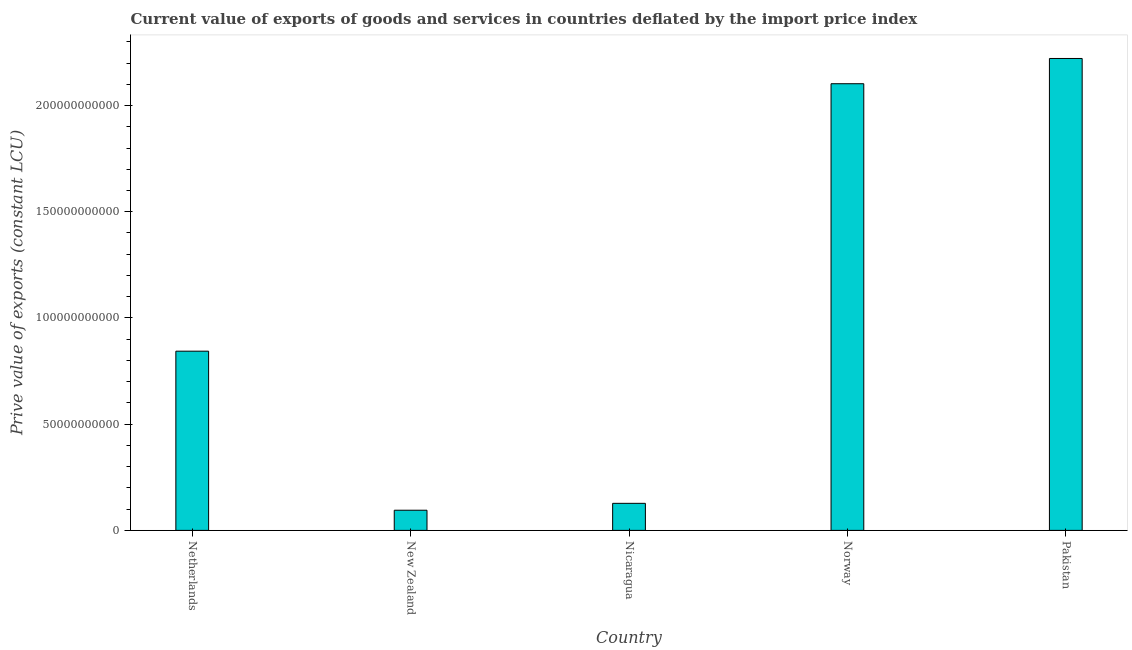Does the graph contain any zero values?
Your answer should be very brief. No. What is the title of the graph?
Keep it short and to the point. Current value of exports of goods and services in countries deflated by the import price index. What is the label or title of the X-axis?
Your answer should be compact. Country. What is the label or title of the Y-axis?
Offer a terse response. Prive value of exports (constant LCU). What is the price value of exports in New Zealand?
Keep it short and to the point. 9.49e+09. Across all countries, what is the maximum price value of exports?
Your answer should be compact. 2.22e+11. Across all countries, what is the minimum price value of exports?
Give a very brief answer. 9.49e+09. In which country was the price value of exports maximum?
Make the answer very short. Pakistan. In which country was the price value of exports minimum?
Keep it short and to the point. New Zealand. What is the sum of the price value of exports?
Offer a very short reply. 5.39e+11. What is the difference between the price value of exports in New Zealand and Norway?
Ensure brevity in your answer.  -2.01e+11. What is the average price value of exports per country?
Your answer should be compact. 1.08e+11. What is the median price value of exports?
Your answer should be compact. 8.44e+1. What is the ratio of the price value of exports in New Zealand to that in Pakistan?
Provide a short and direct response. 0.04. What is the difference between the highest and the second highest price value of exports?
Make the answer very short. 1.19e+1. Is the sum of the price value of exports in Nicaragua and Pakistan greater than the maximum price value of exports across all countries?
Keep it short and to the point. Yes. What is the difference between the highest and the lowest price value of exports?
Keep it short and to the point. 2.13e+11. How many bars are there?
Offer a very short reply. 5. Are all the bars in the graph horizontal?
Offer a very short reply. No. What is the difference between two consecutive major ticks on the Y-axis?
Ensure brevity in your answer.  5.00e+1. Are the values on the major ticks of Y-axis written in scientific E-notation?
Give a very brief answer. No. What is the Prive value of exports (constant LCU) of Netherlands?
Provide a short and direct response. 8.44e+1. What is the Prive value of exports (constant LCU) in New Zealand?
Your answer should be compact. 9.49e+09. What is the Prive value of exports (constant LCU) in Nicaragua?
Make the answer very short. 1.27e+1. What is the Prive value of exports (constant LCU) of Norway?
Provide a succinct answer. 2.10e+11. What is the Prive value of exports (constant LCU) in Pakistan?
Provide a short and direct response. 2.22e+11. What is the difference between the Prive value of exports (constant LCU) in Netherlands and New Zealand?
Your answer should be compact. 7.49e+1. What is the difference between the Prive value of exports (constant LCU) in Netherlands and Nicaragua?
Provide a short and direct response. 7.16e+1. What is the difference between the Prive value of exports (constant LCU) in Netherlands and Norway?
Offer a terse response. -1.26e+11. What is the difference between the Prive value of exports (constant LCU) in Netherlands and Pakistan?
Keep it short and to the point. -1.38e+11. What is the difference between the Prive value of exports (constant LCU) in New Zealand and Nicaragua?
Provide a short and direct response. -3.24e+09. What is the difference between the Prive value of exports (constant LCU) in New Zealand and Norway?
Provide a succinct answer. -2.01e+11. What is the difference between the Prive value of exports (constant LCU) in New Zealand and Pakistan?
Offer a very short reply. -2.13e+11. What is the difference between the Prive value of exports (constant LCU) in Nicaragua and Norway?
Provide a succinct answer. -1.98e+11. What is the difference between the Prive value of exports (constant LCU) in Nicaragua and Pakistan?
Your answer should be very brief. -2.09e+11. What is the difference between the Prive value of exports (constant LCU) in Norway and Pakistan?
Ensure brevity in your answer.  -1.19e+1. What is the ratio of the Prive value of exports (constant LCU) in Netherlands to that in New Zealand?
Ensure brevity in your answer.  8.89. What is the ratio of the Prive value of exports (constant LCU) in Netherlands to that in Nicaragua?
Offer a terse response. 6.62. What is the ratio of the Prive value of exports (constant LCU) in Netherlands to that in Norway?
Offer a very short reply. 0.4. What is the ratio of the Prive value of exports (constant LCU) in Netherlands to that in Pakistan?
Give a very brief answer. 0.38. What is the ratio of the Prive value of exports (constant LCU) in New Zealand to that in Nicaragua?
Give a very brief answer. 0.74. What is the ratio of the Prive value of exports (constant LCU) in New Zealand to that in Norway?
Offer a very short reply. 0.04. What is the ratio of the Prive value of exports (constant LCU) in New Zealand to that in Pakistan?
Your answer should be compact. 0.04. What is the ratio of the Prive value of exports (constant LCU) in Nicaragua to that in Norway?
Your answer should be compact. 0.06. What is the ratio of the Prive value of exports (constant LCU) in Nicaragua to that in Pakistan?
Make the answer very short. 0.06. What is the ratio of the Prive value of exports (constant LCU) in Norway to that in Pakistan?
Offer a very short reply. 0.95. 